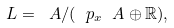<formula> <loc_0><loc_0><loc_500><loc_500>\L L = \ A / ( \ p _ { x } \ A \oplus \mathbb { R } ) ,</formula> 